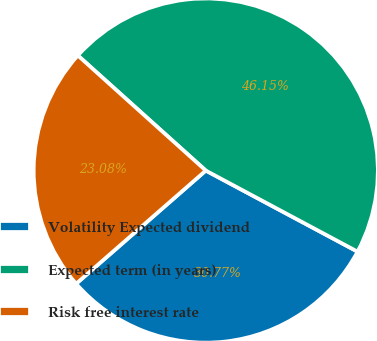Convert chart to OTSL. <chart><loc_0><loc_0><loc_500><loc_500><pie_chart><fcel>Volatility Expected dividend<fcel>Expected term (in years)<fcel>Risk free interest rate<nl><fcel>30.77%<fcel>46.15%<fcel>23.08%<nl></chart> 